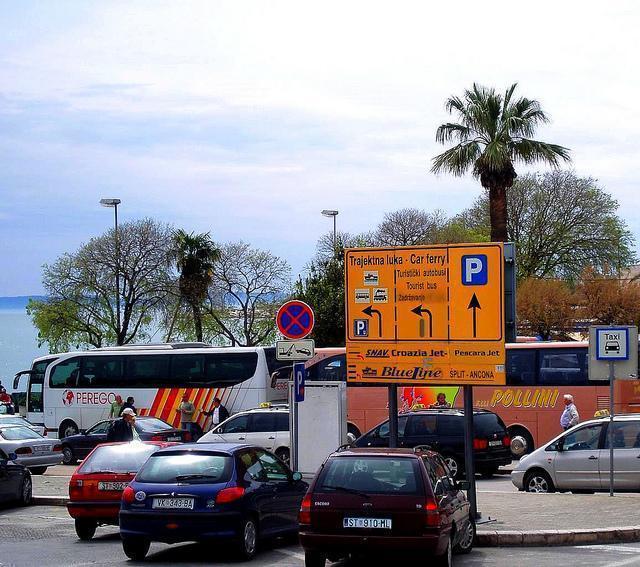How might cars cross the water seen here?
Choose the right answer from the provided options to respond to the question.
Options: Jump over, ferry boat, bridge, driving. Ferry boat. 